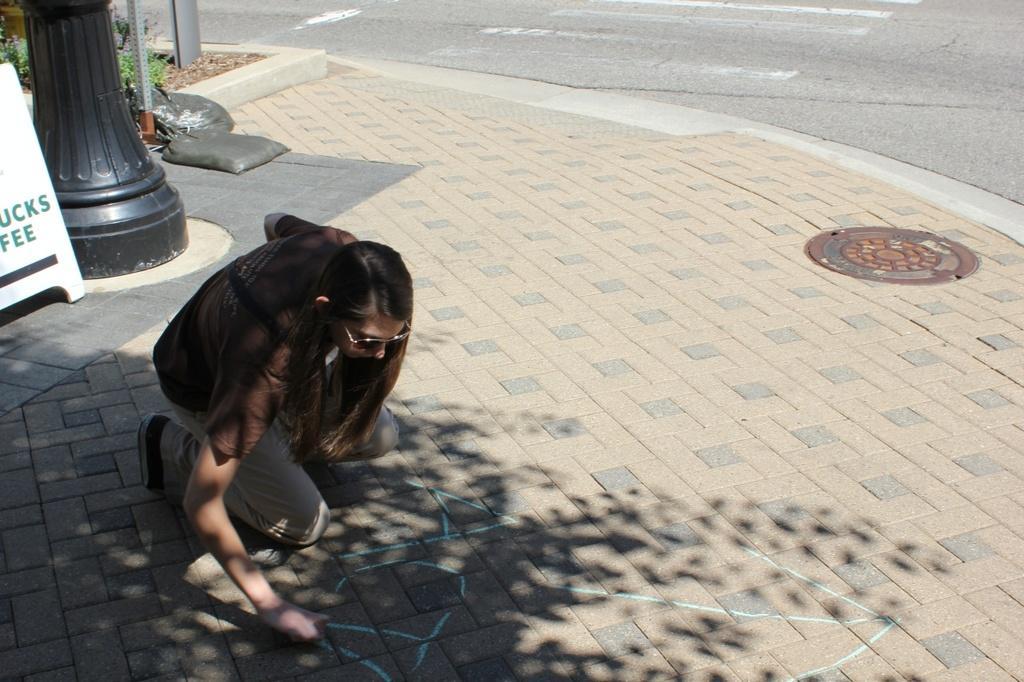Could you give a brief overview of what you see in this image? In the image a woman is sitting and writing. Behind her there is a banner and pole and plants and there are some black color bags. 